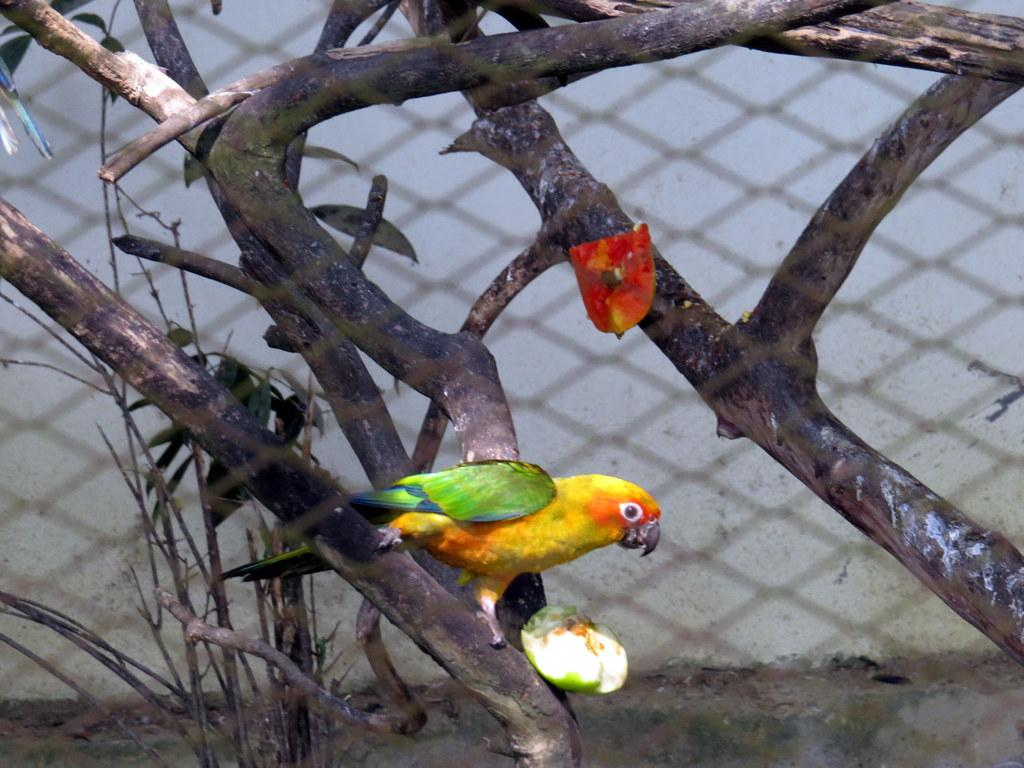What type of natural elements can be seen in the image? There are branches and leaves in the image. What type of animal is present in the image? There is a colorful bird in the image. What type of man-made structure is visible in the image? There is a wall in the image. What type of system is the bird using to navigate the cave in the image? There is no cave present in the image, and therefore no system for the bird to navigate. 